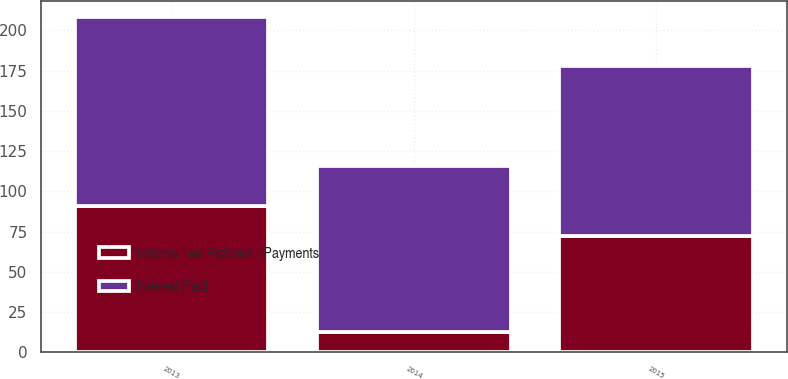<chart> <loc_0><loc_0><loc_500><loc_500><stacked_bar_chart><ecel><fcel>2015<fcel>2014<fcel>2013<nl><fcel>Interest Paid<fcel>106<fcel>103<fcel>117<nl><fcel>Income Tax Refunds / Payments<fcel>72<fcel>13<fcel>91<nl></chart> 